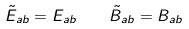Convert formula to latex. <formula><loc_0><loc_0><loc_500><loc_500>\tilde { E } _ { a b } = E _ { a b } \quad \tilde { B } _ { a b } = B _ { a b }</formula> 